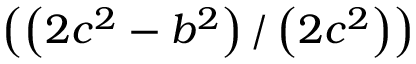<formula> <loc_0><loc_0><loc_500><loc_500>\left ( \left ( 2 c ^ { 2 } - b ^ { 2 } \right ) / \left ( 2 c ^ { 2 } \right ) \right )</formula> 